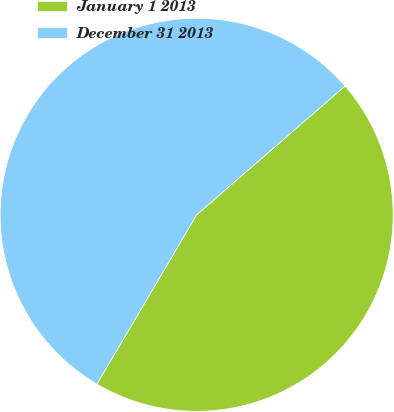Convert chart to OTSL. <chart><loc_0><loc_0><loc_500><loc_500><pie_chart><fcel>January 1 2013<fcel>December 31 2013<nl><fcel>44.85%<fcel>55.15%<nl></chart> 